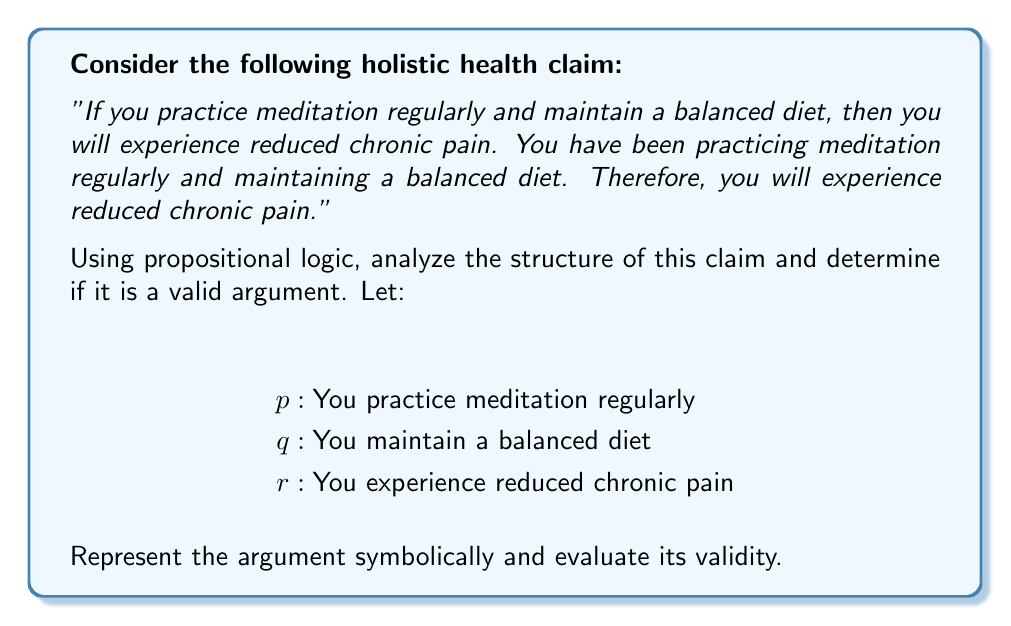Solve this math problem. Let's analyze this argument step-by-step using propositional logic:

1) First, let's represent the argument symbolically:

   Premise 1: $(p \wedge q) \rightarrow r$
   Premise 2: $p \wedge q$
   Conclusion: $r$

2) This argument form is known as Modus Ponens, which has the structure:
   
   $P \rightarrow Q$
   $P$
   $\therefore Q$

3) To prove validity, we can use a truth table:

   $$
   \begin{array}{|c|c|c|c|c|c|}
   \hline
   p & q & r & p \wedge q & (p \wedge q) \rightarrow r & \text{Valid?} \\
   \hline
   T & T & T & T & T & \text{Yes} \\
   T & T & F & T & F & \text{No} \\
   T & F & T & F & T & \text{Yes} \\
   T & F & F & F & T & \text{Yes} \\
   F & T & T & F & T & \text{Yes} \\
   F & T & F & F & T & \text{Yes} \\
   F & F & T & F & T & \text{Yes} \\
   F & F & F & F & T & \text{Yes} \\
   \hline
   \end{array}
   $$

4) From the truth table, we can see that when both premises are true (first row), the conclusion is necessarily true. This means the argument is valid.

5) It's important to note that validity doesn't guarantee truth in the real world. The argument is logically sound, but the truthfulness of the premises would need to be verified empirically.
Answer: The argument is valid. 